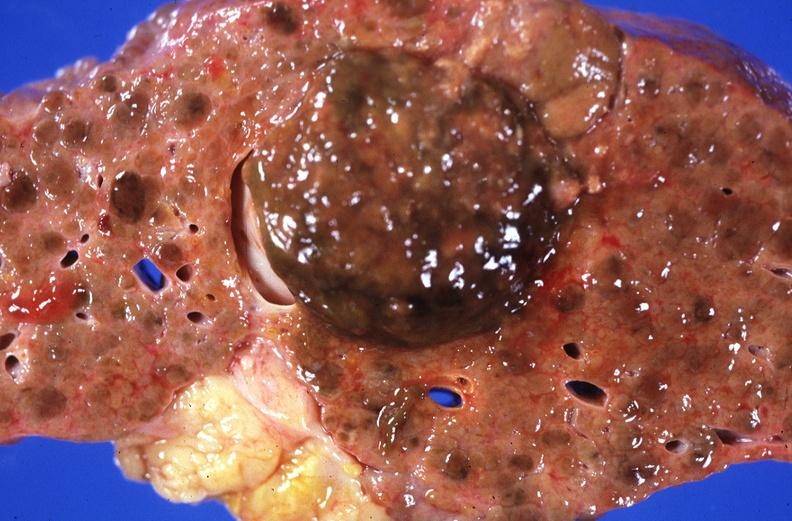what does this image show?
Answer the question using a single word or phrase. Hepatitis b virus 